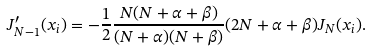Convert formula to latex. <formula><loc_0><loc_0><loc_500><loc_500>J _ { N - 1 } ^ { \prime } ( x _ { i } ) = - \frac { 1 } { 2 } \frac { N ( N + \alpha + \beta ) } { ( N + \alpha ) ( N + \beta ) } ( 2 N + \alpha + \beta ) J _ { N } ( x _ { i } ) .</formula> 